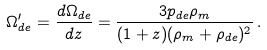Convert formula to latex. <formula><loc_0><loc_0><loc_500><loc_500>\Omega _ { d e } ^ { \prime } = \frac { d \Omega _ { d e } } { d z } = \frac { 3 p _ { d e } \rho _ { m } } { ( 1 + z ) ( \rho _ { m } + \rho _ { d e } ) ^ { 2 } } \, .</formula> 